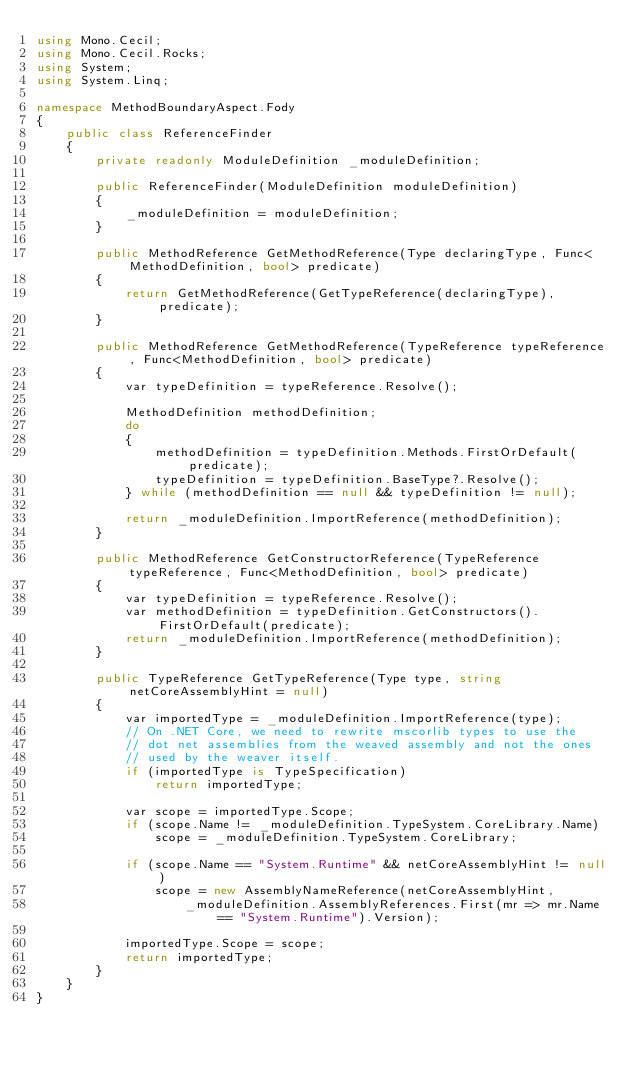<code> <loc_0><loc_0><loc_500><loc_500><_C#_>using Mono.Cecil;
using Mono.Cecil.Rocks;
using System;
using System.Linq;

namespace MethodBoundaryAspect.Fody
{
    public class ReferenceFinder
    {
        private readonly ModuleDefinition _moduleDefinition;

        public ReferenceFinder(ModuleDefinition moduleDefinition)
        {
            _moduleDefinition = moduleDefinition;
        }

        public MethodReference GetMethodReference(Type declaringType, Func<MethodDefinition, bool> predicate)
        {
            return GetMethodReference(GetTypeReference(declaringType), predicate);
        }

        public MethodReference GetMethodReference(TypeReference typeReference, Func<MethodDefinition, bool> predicate)
        {
            var typeDefinition = typeReference.Resolve();

            MethodDefinition methodDefinition;
            do
            {
                methodDefinition = typeDefinition.Methods.FirstOrDefault(predicate);
                typeDefinition = typeDefinition.BaseType?.Resolve();
            } while (methodDefinition == null && typeDefinition != null);

            return _moduleDefinition.ImportReference(methodDefinition);
        }

        public MethodReference GetConstructorReference(TypeReference typeReference, Func<MethodDefinition, bool> predicate)
        {
            var typeDefinition = typeReference.Resolve();
            var methodDefinition = typeDefinition.GetConstructors().FirstOrDefault(predicate);
            return _moduleDefinition.ImportReference(methodDefinition);
        }

        public TypeReference GetTypeReference(Type type, string netCoreAssemblyHint = null)
        {
            var importedType = _moduleDefinition.ImportReference(type);
            // On .NET Core, we need to rewrite mscorlib types to use the
            // dot net assemblies from the weaved assembly and not the ones
            // used by the weaver itself.
            if (importedType is TypeSpecification)
                return importedType;

            var scope = importedType.Scope;
            if (scope.Name != _moduleDefinition.TypeSystem.CoreLibrary.Name)
                scope = _moduleDefinition.TypeSystem.CoreLibrary;

            if (scope.Name == "System.Runtime" && netCoreAssemblyHint != null)
                scope = new AssemblyNameReference(netCoreAssemblyHint,
                    _moduleDefinition.AssemblyReferences.First(mr => mr.Name == "System.Runtime").Version);

            importedType.Scope = scope;
            return importedType;
        }
    }
}</code> 